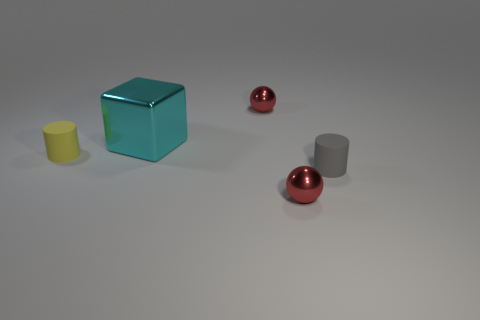Are there any large shiny objects?
Keep it short and to the point. Yes. What is the color of the shiny sphere that is in front of the big cyan shiny block?
Offer a very short reply. Red. Are there any tiny yellow objects behind the big cyan metallic cube?
Give a very brief answer. No. Are there more gray matte things than red balls?
Make the answer very short. No. What is the color of the large shiny thing left of the small red metallic ball that is to the right of the metallic ball that is behind the cube?
Provide a short and direct response. Cyan. There is another object that is made of the same material as the tiny yellow object; what is its color?
Your answer should be compact. Gray. Are there any other things that have the same size as the yellow matte cylinder?
Your response must be concise. Yes. How many things are small metallic things that are behind the cyan shiny thing or shiny balls behind the large object?
Keep it short and to the point. 1. Do the red thing that is in front of the tiny gray matte cylinder and the rubber cylinder in front of the tiny yellow matte cylinder have the same size?
Your answer should be very brief. Yes. What is the color of the other matte thing that is the same shape as the small yellow thing?
Keep it short and to the point. Gray. 